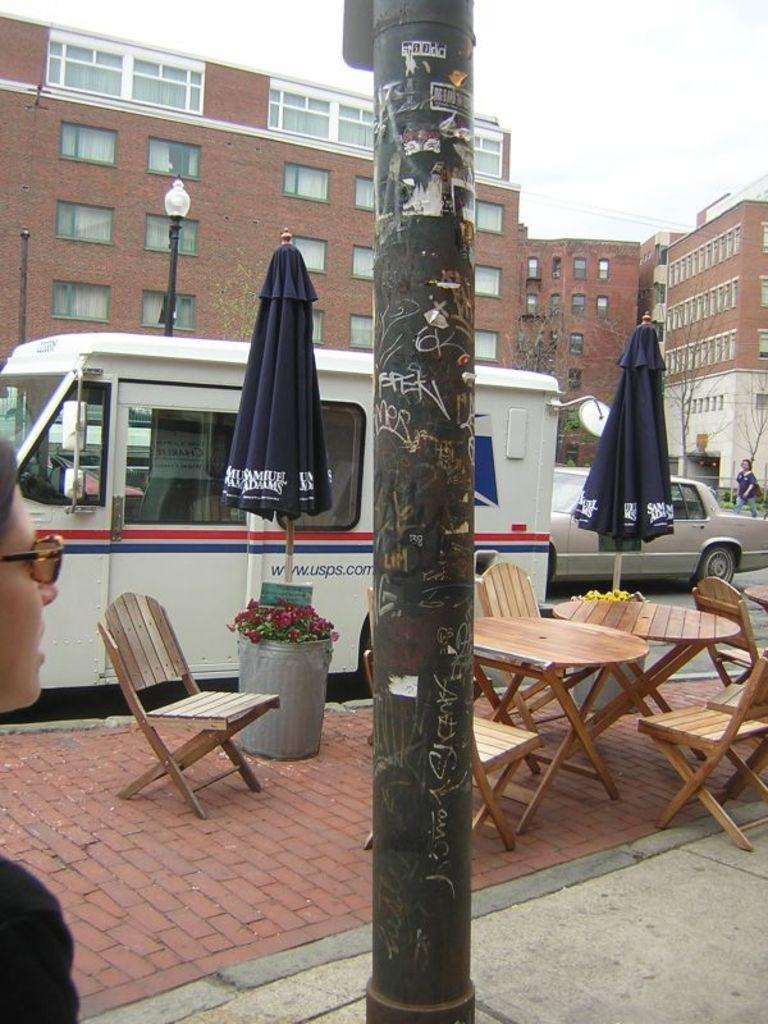What type of furniture is present in the image? There is a table and chairs in the image. Where are the table and chairs located? The table and chairs are on a footpath in the image. What can be seen parked on the road in the image? Cars and vans are parked on the road in the image. What is visible in the background of the image? There are buildings visible in the background of the image. What type of salt is being used to decorate the table in the image? There is no salt present in the image; it features a table and chairs on a footpath with parked cars and vans nearby. Can you see a flag flying in the image? There is no flag visible in the image. 